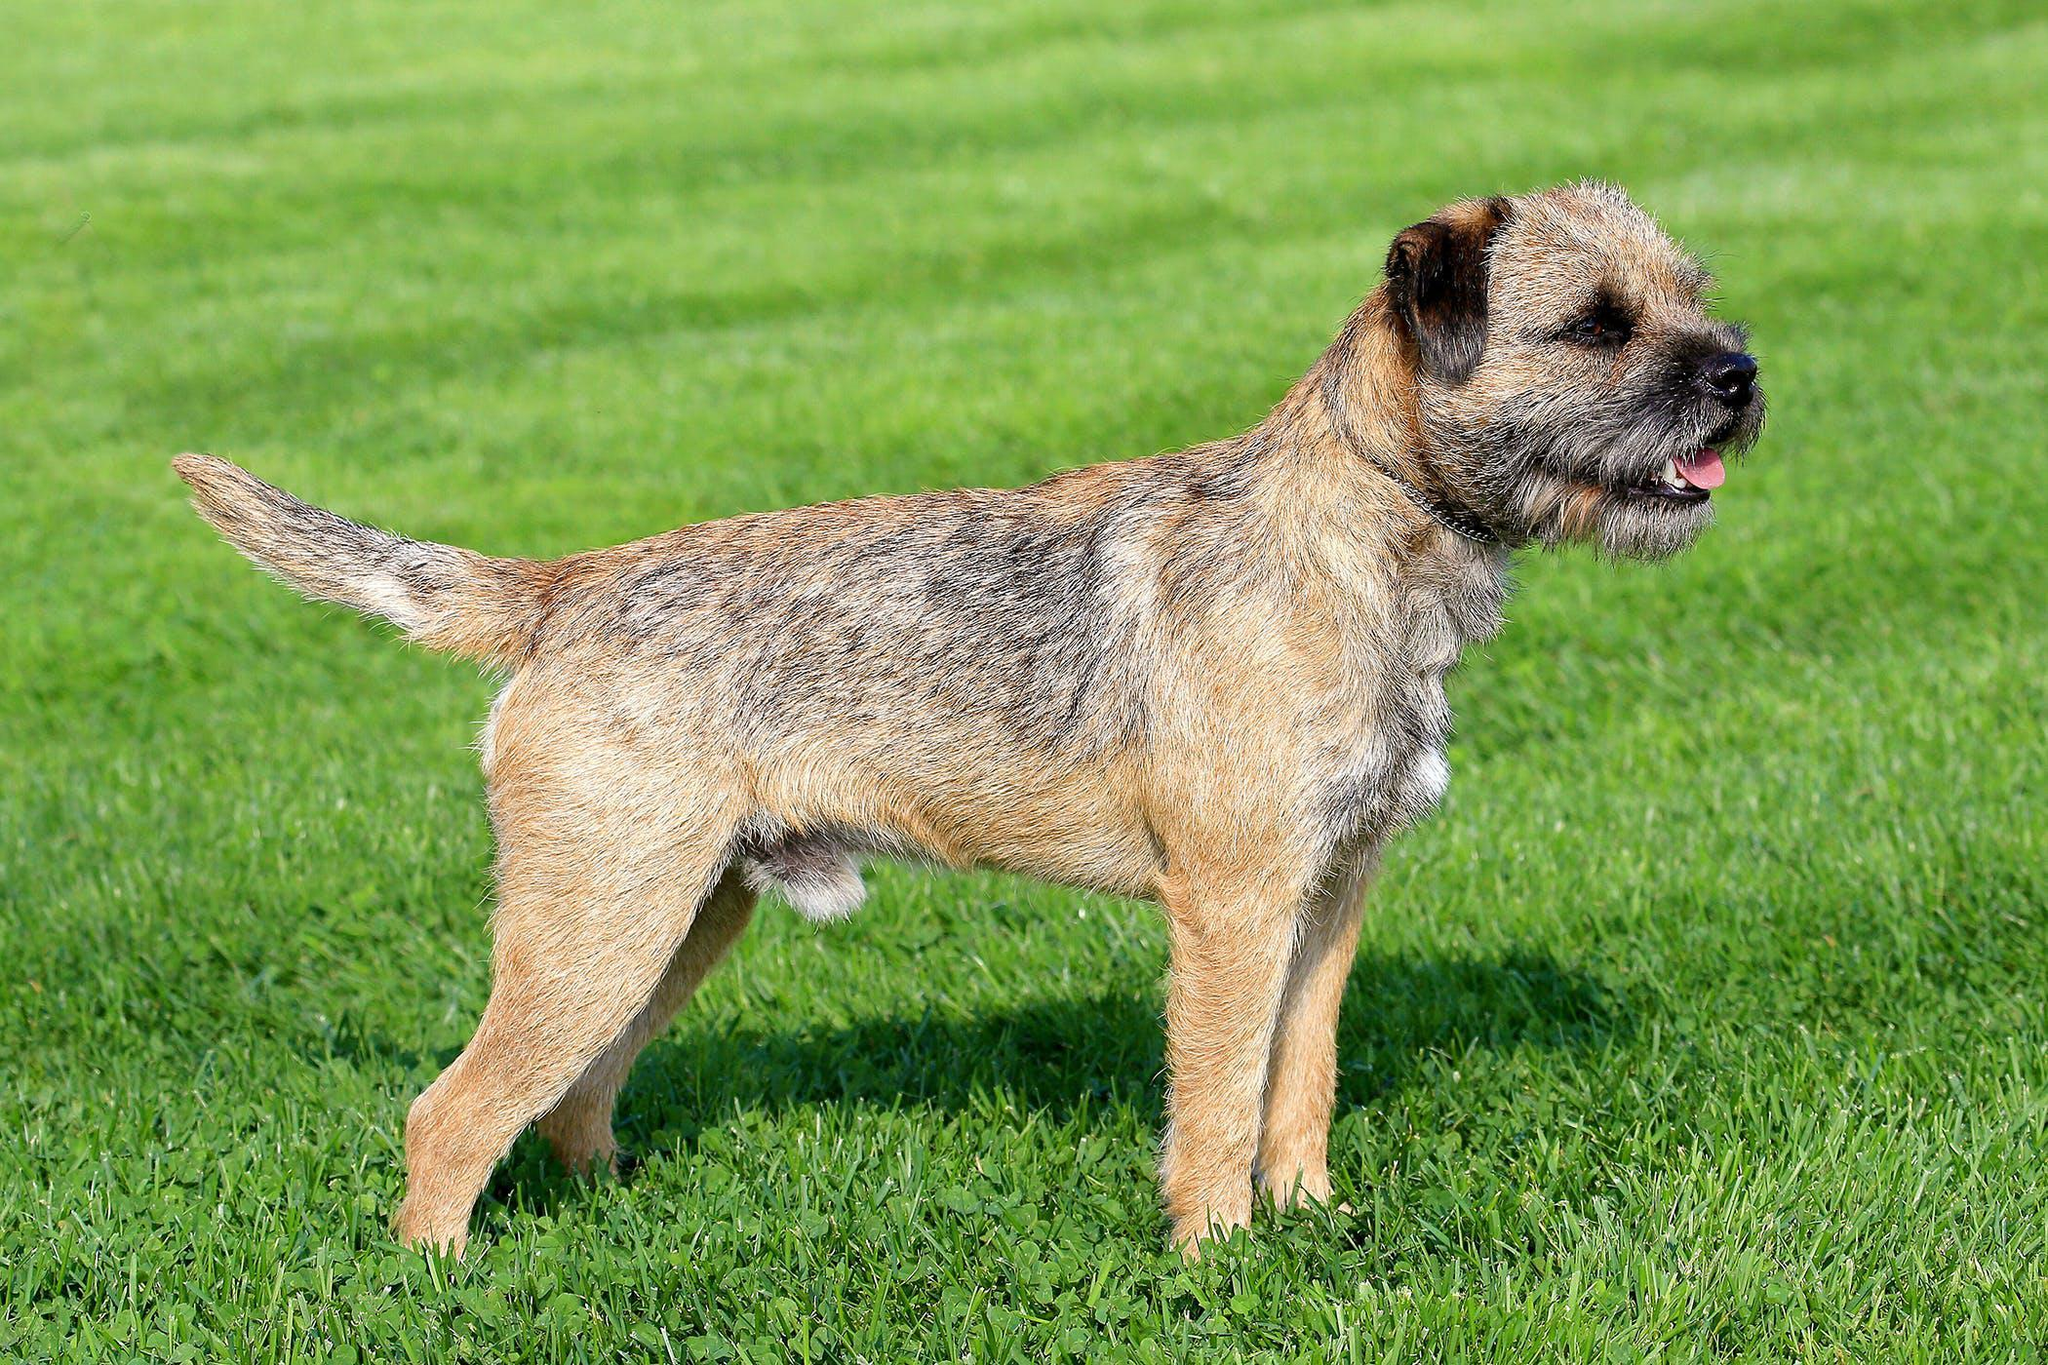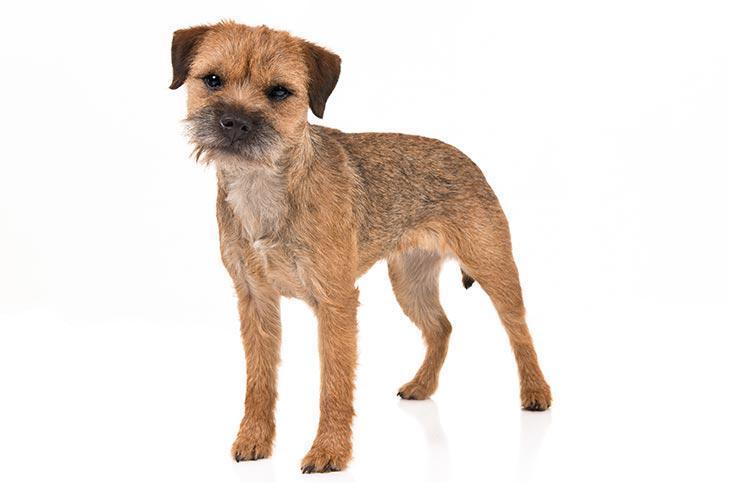The first image is the image on the left, the second image is the image on the right. For the images displayed, is the sentence "A dog has a front paw off the ground." factually correct? Answer yes or no. No. The first image is the image on the left, the second image is the image on the right. For the images displayed, is the sentence "The left image features one dog in a sitting pose, and the right image shows a dog gazing at the camera and standing up on at least three feet." factually correct? Answer yes or no. No. 